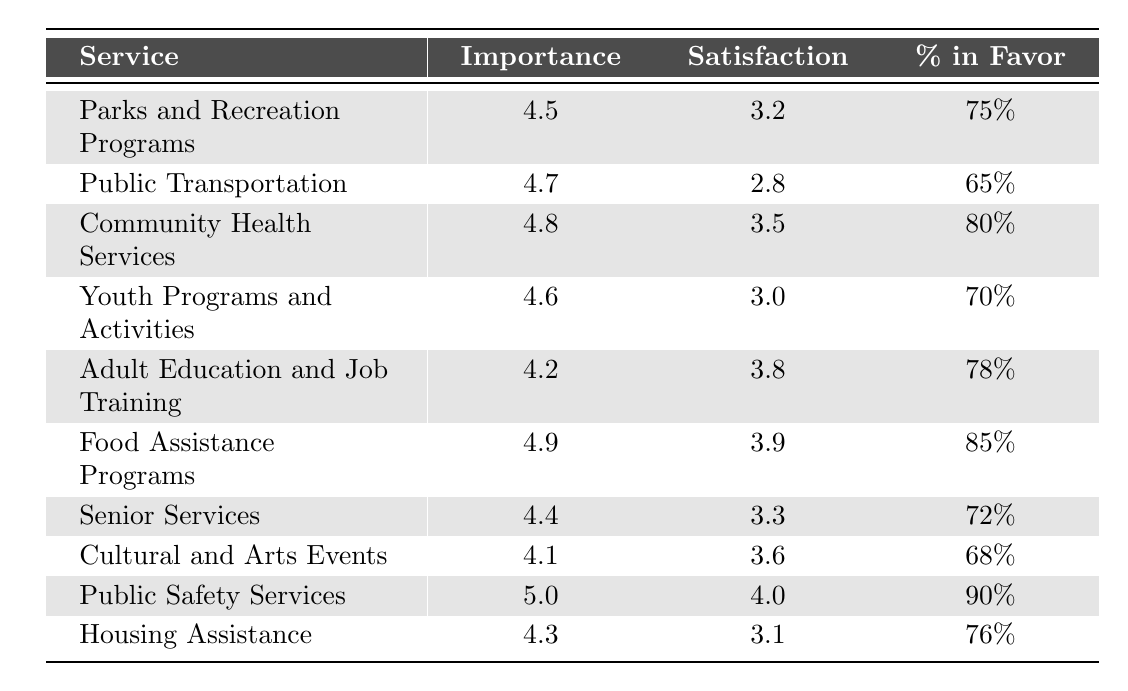What is the service with the highest importance rating? By reviewing the table, we can see the "Public Safety Services" has an importance rating of 5.0, which is the highest among all listed services.
Answer: Public Safety Services What is the satisfaction rating of Food Assistance Programs? In the table, "Food Assistance Programs" has a satisfaction rating of 3.9.
Answer: 3.9 What percentage of respondents favored Cultural and Arts Events? According to the table, "Cultural and Arts Events" received a favor percentage of 68%.
Answer: 68% Is the overall satisfaction rating for Public Transportation above 3.0? The table indicates that "Public Transportation" has a satisfaction rating of 2.8, which is below 3.0.
Answer: No Which service has the lowest satisfaction rating? Looking at the table, "Public Transportation" shows the lowest satisfaction rating at 2.8.
Answer: Public Transportation What is the difference in satisfaction ratings between Community Health Services and Senior Services? The satisfaction rating for "Community Health Services" is 3.5 and for "Senior Services" is 3.3, so the difference is 3.5 - 3.3 = 0.2.
Answer: 0.2 Which service has both a high importance and high satisfaction rating? "Public Safety Services" stands out as it has the highest importance rating of 5.0 and a satisfaction rating of 4.0, indicating both high importance and high satisfaction.
Answer: Public Safety Services What is the average importance rating of all services listed? To find the average importance rating, we sum the importance ratings: (4.5 + 4.7 + 4.8 + 4.6 + 4.2 + 4.9 + 4.4 + 4.1 + 5.0 + 4.3) = 46.5 and divide by the number of services, which is 10. Therefore, the average is 46.5 / 10 = 4.65.
Answer: 4.65 How many services have a satisfaction rating of 3.5 or higher? By checking the satisfaction ratings, the services with ratings of 3.5 or higher are Community Health Services, Food Assistance Programs, Adult Education and Job Training, and Public Safety Services, totaling 4 services.
Answer: 4 Is there a service with an importance rating below 4.0? The table shows that the lowest importance rating is 4.1 for "Cultural and Arts Events," which is below 4.0.
Answer: Yes 